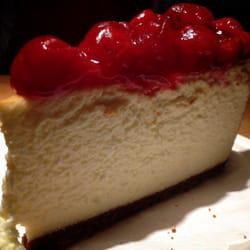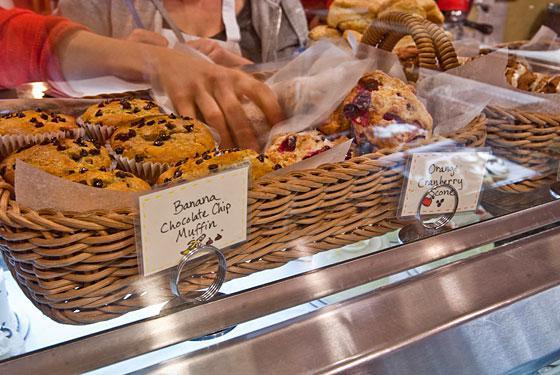The first image is the image on the left, the second image is the image on the right. Evaluate the accuracy of this statement regarding the images: "There is a human hand reaching for a dessert.". Is it true? Answer yes or no. Yes. 